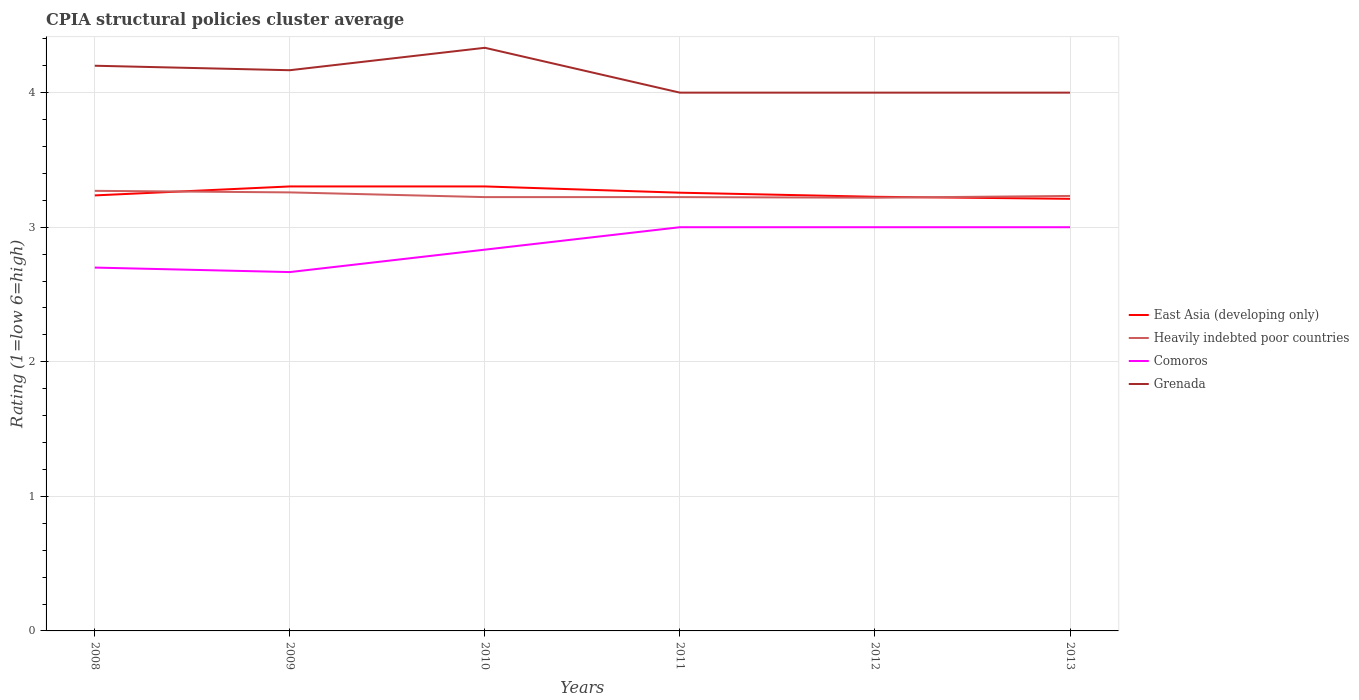How many different coloured lines are there?
Your response must be concise. 4. Is the number of lines equal to the number of legend labels?
Offer a terse response. Yes. Across all years, what is the maximum CPIA rating in East Asia (developing only)?
Offer a very short reply. 3.21. In which year was the CPIA rating in Grenada maximum?
Give a very brief answer. 2011. What is the total CPIA rating in Comoros in the graph?
Provide a succinct answer. 0.03. What is the difference between the highest and the second highest CPIA rating in Comoros?
Offer a very short reply. 0.33. How many lines are there?
Provide a succinct answer. 4. Does the graph contain any zero values?
Your answer should be compact. No. Where does the legend appear in the graph?
Provide a short and direct response. Center right. How many legend labels are there?
Offer a very short reply. 4. How are the legend labels stacked?
Make the answer very short. Vertical. What is the title of the graph?
Provide a succinct answer. CPIA structural policies cluster average. What is the Rating (1=low 6=high) in East Asia (developing only) in 2008?
Make the answer very short. 3.24. What is the Rating (1=low 6=high) of Heavily indebted poor countries in 2008?
Provide a succinct answer. 3.27. What is the Rating (1=low 6=high) of Comoros in 2008?
Your answer should be compact. 2.7. What is the Rating (1=low 6=high) of Grenada in 2008?
Make the answer very short. 4.2. What is the Rating (1=low 6=high) of East Asia (developing only) in 2009?
Provide a succinct answer. 3.3. What is the Rating (1=low 6=high) of Heavily indebted poor countries in 2009?
Your response must be concise. 3.26. What is the Rating (1=low 6=high) in Comoros in 2009?
Ensure brevity in your answer.  2.67. What is the Rating (1=low 6=high) in Grenada in 2009?
Keep it short and to the point. 4.17. What is the Rating (1=low 6=high) of East Asia (developing only) in 2010?
Your answer should be very brief. 3.3. What is the Rating (1=low 6=high) of Heavily indebted poor countries in 2010?
Your answer should be very brief. 3.22. What is the Rating (1=low 6=high) in Comoros in 2010?
Offer a very short reply. 2.83. What is the Rating (1=low 6=high) in Grenada in 2010?
Your answer should be very brief. 4.33. What is the Rating (1=low 6=high) of East Asia (developing only) in 2011?
Ensure brevity in your answer.  3.26. What is the Rating (1=low 6=high) in Heavily indebted poor countries in 2011?
Give a very brief answer. 3.22. What is the Rating (1=low 6=high) of Grenada in 2011?
Your answer should be very brief. 4. What is the Rating (1=low 6=high) of East Asia (developing only) in 2012?
Ensure brevity in your answer.  3.23. What is the Rating (1=low 6=high) in Heavily indebted poor countries in 2012?
Provide a succinct answer. 3.22. What is the Rating (1=low 6=high) of Comoros in 2012?
Your answer should be compact. 3. What is the Rating (1=low 6=high) in Grenada in 2012?
Provide a short and direct response. 4. What is the Rating (1=low 6=high) in East Asia (developing only) in 2013?
Ensure brevity in your answer.  3.21. What is the Rating (1=low 6=high) of Heavily indebted poor countries in 2013?
Provide a succinct answer. 3.23. What is the Rating (1=low 6=high) in Comoros in 2013?
Provide a short and direct response. 3. What is the Rating (1=low 6=high) of Grenada in 2013?
Ensure brevity in your answer.  4. Across all years, what is the maximum Rating (1=low 6=high) of East Asia (developing only)?
Your answer should be very brief. 3.3. Across all years, what is the maximum Rating (1=low 6=high) of Heavily indebted poor countries?
Provide a short and direct response. 3.27. Across all years, what is the maximum Rating (1=low 6=high) of Comoros?
Offer a terse response. 3. Across all years, what is the maximum Rating (1=low 6=high) of Grenada?
Keep it short and to the point. 4.33. Across all years, what is the minimum Rating (1=low 6=high) of East Asia (developing only)?
Provide a succinct answer. 3.21. Across all years, what is the minimum Rating (1=low 6=high) of Heavily indebted poor countries?
Provide a short and direct response. 3.22. Across all years, what is the minimum Rating (1=low 6=high) in Comoros?
Provide a short and direct response. 2.67. Across all years, what is the minimum Rating (1=low 6=high) in Grenada?
Your response must be concise. 4. What is the total Rating (1=low 6=high) of East Asia (developing only) in the graph?
Offer a terse response. 19.54. What is the total Rating (1=low 6=high) of Heavily indebted poor countries in the graph?
Provide a short and direct response. 19.43. What is the total Rating (1=low 6=high) of Grenada in the graph?
Make the answer very short. 24.7. What is the difference between the Rating (1=low 6=high) of East Asia (developing only) in 2008 and that in 2009?
Provide a succinct answer. -0.07. What is the difference between the Rating (1=low 6=high) of Heavily indebted poor countries in 2008 and that in 2009?
Ensure brevity in your answer.  0.01. What is the difference between the Rating (1=low 6=high) of East Asia (developing only) in 2008 and that in 2010?
Your answer should be very brief. -0.07. What is the difference between the Rating (1=low 6=high) in Heavily indebted poor countries in 2008 and that in 2010?
Provide a short and direct response. 0.05. What is the difference between the Rating (1=low 6=high) in Comoros in 2008 and that in 2010?
Make the answer very short. -0.13. What is the difference between the Rating (1=low 6=high) in Grenada in 2008 and that in 2010?
Make the answer very short. -0.13. What is the difference between the Rating (1=low 6=high) of East Asia (developing only) in 2008 and that in 2011?
Your response must be concise. -0.02. What is the difference between the Rating (1=low 6=high) in Heavily indebted poor countries in 2008 and that in 2011?
Make the answer very short. 0.05. What is the difference between the Rating (1=low 6=high) of Comoros in 2008 and that in 2011?
Give a very brief answer. -0.3. What is the difference between the Rating (1=low 6=high) of Grenada in 2008 and that in 2011?
Keep it short and to the point. 0.2. What is the difference between the Rating (1=low 6=high) of East Asia (developing only) in 2008 and that in 2012?
Keep it short and to the point. 0.01. What is the difference between the Rating (1=low 6=high) in Heavily indebted poor countries in 2008 and that in 2012?
Offer a terse response. 0.05. What is the difference between the Rating (1=low 6=high) in East Asia (developing only) in 2008 and that in 2013?
Keep it short and to the point. 0.03. What is the difference between the Rating (1=low 6=high) of Heavily indebted poor countries in 2008 and that in 2013?
Your answer should be very brief. 0.04. What is the difference between the Rating (1=low 6=high) of Heavily indebted poor countries in 2009 and that in 2010?
Give a very brief answer. 0.04. What is the difference between the Rating (1=low 6=high) in Comoros in 2009 and that in 2010?
Offer a very short reply. -0.17. What is the difference between the Rating (1=low 6=high) of East Asia (developing only) in 2009 and that in 2011?
Make the answer very short. 0.05. What is the difference between the Rating (1=low 6=high) in Heavily indebted poor countries in 2009 and that in 2011?
Your response must be concise. 0.04. What is the difference between the Rating (1=low 6=high) in Grenada in 2009 and that in 2011?
Your answer should be compact. 0.17. What is the difference between the Rating (1=low 6=high) of East Asia (developing only) in 2009 and that in 2012?
Make the answer very short. 0.08. What is the difference between the Rating (1=low 6=high) in Heavily indebted poor countries in 2009 and that in 2012?
Your response must be concise. 0.04. What is the difference between the Rating (1=low 6=high) in Comoros in 2009 and that in 2012?
Give a very brief answer. -0.33. What is the difference between the Rating (1=low 6=high) of East Asia (developing only) in 2009 and that in 2013?
Keep it short and to the point. 0.09. What is the difference between the Rating (1=low 6=high) in Heavily indebted poor countries in 2009 and that in 2013?
Provide a short and direct response. 0.03. What is the difference between the Rating (1=low 6=high) of East Asia (developing only) in 2010 and that in 2011?
Give a very brief answer. 0.05. What is the difference between the Rating (1=low 6=high) of Heavily indebted poor countries in 2010 and that in 2011?
Provide a short and direct response. 0. What is the difference between the Rating (1=low 6=high) of Grenada in 2010 and that in 2011?
Keep it short and to the point. 0.33. What is the difference between the Rating (1=low 6=high) in East Asia (developing only) in 2010 and that in 2012?
Offer a very short reply. 0.08. What is the difference between the Rating (1=low 6=high) of Heavily indebted poor countries in 2010 and that in 2012?
Your answer should be compact. 0. What is the difference between the Rating (1=low 6=high) in East Asia (developing only) in 2010 and that in 2013?
Provide a short and direct response. 0.09. What is the difference between the Rating (1=low 6=high) of Heavily indebted poor countries in 2010 and that in 2013?
Your answer should be very brief. -0.01. What is the difference between the Rating (1=low 6=high) of East Asia (developing only) in 2011 and that in 2012?
Offer a terse response. 0.03. What is the difference between the Rating (1=low 6=high) of Heavily indebted poor countries in 2011 and that in 2012?
Make the answer very short. 0. What is the difference between the Rating (1=low 6=high) in East Asia (developing only) in 2011 and that in 2013?
Make the answer very short. 0.05. What is the difference between the Rating (1=low 6=high) in Heavily indebted poor countries in 2011 and that in 2013?
Your answer should be compact. -0.01. What is the difference between the Rating (1=low 6=high) in East Asia (developing only) in 2012 and that in 2013?
Ensure brevity in your answer.  0.02. What is the difference between the Rating (1=low 6=high) in Heavily indebted poor countries in 2012 and that in 2013?
Make the answer very short. -0.01. What is the difference between the Rating (1=low 6=high) of East Asia (developing only) in 2008 and the Rating (1=low 6=high) of Heavily indebted poor countries in 2009?
Offer a very short reply. -0.02. What is the difference between the Rating (1=low 6=high) of East Asia (developing only) in 2008 and the Rating (1=low 6=high) of Comoros in 2009?
Make the answer very short. 0.57. What is the difference between the Rating (1=low 6=high) in East Asia (developing only) in 2008 and the Rating (1=low 6=high) in Grenada in 2009?
Keep it short and to the point. -0.93. What is the difference between the Rating (1=low 6=high) of Heavily indebted poor countries in 2008 and the Rating (1=low 6=high) of Comoros in 2009?
Offer a terse response. 0.6. What is the difference between the Rating (1=low 6=high) in Heavily indebted poor countries in 2008 and the Rating (1=low 6=high) in Grenada in 2009?
Offer a very short reply. -0.9. What is the difference between the Rating (1=low 6=high) in Comoros in 2008 and the Rating (1=low 6=high) in Grenada in 2009?
Your answer should be very brief. -1.47. What is the difference between the Rating (1=low 6=high) in East Asia (developing only) in 2008 and the Rating (1=low 6=high) in Heavily indebted poor countries in 2010?
Provide a short and direct response. 0.01. What is the difference between the Rating (1=low 6=high) of East Asia (developing only) in 2008 and the Rating (1=low 6=high) of Comoros in 2010?
Your response must be concise. 0.4. What is the difference between the Rating (1=low 6=high) of East Asia (developing only) in 2008 and the Rating (1=low 6=high) of Grenada in 2010?
Ensure brevity in your answer.  -1.1. What is the difference between the Rating (1=low 6=high) in Heavily indebted poor countries in 2008 and the Rating (1=low 6=high) in Comoros in 2010?
Offer a terse response. 0.44. What is the difference between the Rating (1=low 6=high) of Heavily indebted poor countries in 2008 and the Rating (1=low 6=high) of Grenada in 2010?
Your response must be concise. -1.06. What is the difference between the Rating (1=low 6=high) in Comoros in 2008 and the Rating (1=low 6=high) in Grenada in 2010?
Offer a terse response. -1.63. What is the difference between the Rating (1=low 6=high) in East Asia (developing only) in 2008 and the Rating (1=low 6=high) in Heavily indebted poor countries in 2011?
Your response must be concise. 0.01. What is the difference between the Rating (1=low 6=high) in East Asia (developing only) in 2008 and the Rating (1=low 6=high) in Comoros in 2011?
Offer a very short reply. 0.24. What is the difference between the Rating (1=low 6=high) in East Asia (developing only) in 2008 and the Rating (1=low 6=high) in Grenada in 2011?
Your answer should be compact. -0.76. What is the difference between the Rating (1=low 6=high) in Heavily indebted poor countries in 2008 and the Rating (1=low 6=high) in Comoros in 2011?
Provide a short and direct response. 0.27. What is the difference between the Rating (1=low 6=high) in Heavily indebted poor countries in 2008 and the Rating (1=low 6=high) in Grenada in 2011?
Provide a short and direct response. -0.73. What is the difference between the Rating (1=low 6=high) in Comoros in 2008 and the Rating (1=low 6=high) in Grenada in 2011?
Give a very brief answer. -1.3. What is the difference between the Rating (1=low 6=high) in East Asia (developing only) in 2008 and the Rating (1=low 6=high) in Heavily indebted poor countries in 2012?
Offer a terse response. 0.02. What is the difference between the Rating (1=low 6=high) of East Asia (developing only) in 2008 and the Rating (1=low 6=high) of Comoros in 2012?
Make the answer very short. 0.24. What is the difference between the Rating (1=low 6=high) of East Asia (developing only) in 2008 and the Rating (1=low 6=high) of Grenada in 2012?
Provide a short and direct response. -0.76. What is the difference between the Rating (1=low 6=high) in Heavily indebted poor countries in 2008 and the Rating (1=low 6=high) in Comoros in 2012?
Your answer should be very brief. 0.27. What is the difference between the Rating (1=low 6=high) of Heavily indebted poor countries in 2008 and the Rating (1=low 6=high) of Grenada in 2012?
Provide a short and direct response. -0.73. What is the difference between the Rating (1=low 6=high) in East Asia (developing only) in 2008 and the Rating (1=low 6=high) in Heavily indebted poor countries in 2013?
Offer a terse response. 0. What is the difference between the Rating (1=low 6=high) of East Asia (developing only) in 2008 and the Rating (1=low 6=high) of Comoros in 2013?
Your response must be concise. 0.24. What is the difference between the Rating (1=low 6=high) of East Asia (developing only) in 2008 and the Rating (1=low 6=high) of Grenada in 2013?
Your answer should be compact. -0.76. What is the difference between the Rating (1=low 6=high) of Heavily indebted poor countries in 2008 and the Rating (1=low 6=high) of Comoros in 2013?
Your response must be concise. 0.27. What is the difference between the Rating (1=low 6=high) in Heavily indebted poor countries in 2008 and the Rating (1=low 6=high) in Grenada in 2013?
Your answer should be very brief. -0.73. What is the difference between the Rating (1=low 6=high) in East Asia (developing only) in 2009 and the Rating (1=low 6=high) in Heavily indebted poor countries in 2010?
Make the answer very short. 0.08. What is the difference between the Rating (1=low 6=high) of East Asia (developing only) in 2009 and the Rating (1=low 6=high) of Comoros in 2010?
Make the answer very short. 0.47. What is the difference between the Rating (1=low 6=high) of East Asia (developing only) in 2009 and the Rating (1=low 6=high) of Grenada in 2010?
Offer a terse response. -1.03. What is the difference between the Rating (1=low 6=high) in Heavily indebted poor countries in 2009 and the Rating (1=low 6=high) in Comoros in 2010?
Your response must be concise. 0.43. What is the difference between the Rating (1=low 6=high) of Heavily indebted poor countries in 2009 and the Rating (1=low 6=high) of Grenada in 2010?
Offer a very short reply. -1.07. What is the difference between the Rating (1=low 6=high) in Comoros in 2009 and the Rating (1=low 6=high) in Grenada in 2010?
Your response must be concise. -1.67. What is the difference between the Rating (1=low 6=high) in East Asia (developing only) in 2009 and the Rating (1=low 6=high) in Heavily indebted poor countries in 2011?
Provide a succinct answer. 0.08. What is the difference between the Rating (1=low 6=high) in East Asia (developing only) in 2009 and the Rating (1=low 6=high) in Comoros in 2011?
Offer a terse response. 0.3. What is the difference between the Rating (1=low 6=high) in East Asia (developing only) in 2009 and the Rating (1=low 6=high) in Grenada in 2011?
Your answer should be very brief. -0.7. What is the difference between the Rating (1=low 6=high) in Heavily indebted poor countries in 2009 and the Rating (1=low 6=high) in Comoros in 2011?
Ensure brevity in your answer.  0.26. What is the difference between the Rating (1=low 6=high) in Heavily indebted poor countries in 2009 and the Rating (1=low 6=high) in Grenada in 2011?
Your response must be concise. -0.74. What is the difference between the Rating (1=low 6=high) in Comoros in 2009 and the Rating (1=low 6=high) in Grenada in 2011?
Your answer should be very brief. -1.33. What is the difference between the Rating (1=low 6=high) in East Asia (developing only) in 2009 and the Rating (1=low 6=high) in Heavily indebted poor countries in 2012?
Your answer should be very brief. 0.08. What is the difference between the Rating (1=low 6=high) of East Asia (developing only) in 2009 and the Rating (1=low 6=high) of Comoros in 2012?
Your answer should be compact. 0.3. What is the difference between the Rating (1=low 6=high) in East Asia (developing only) in 2009 and the Rating (1=low 6=high) in Grenada in 2012?
Offer a very short reply. -0.7. What is the difference between the Rating (1=low 6=high) of Heavily indebted poor countries in 2009 and the Rating (1=low 6=high) of Comoros in 2012?
Offer a very short reply. 0.26. What is the difference between the Rating (1=low 6=high) in Heavily indebted poor countries in 2009 and the Rating (1=low 6=high) in Grenada in 2012?
Provide a short and direct response. -0.74. What is the difference between the Rating (1=low 6=high) of Comoros in 2009 and the Rating (1=low 6=high) of Grenada in 2012?
Make the answer very short. -1.33. What is the difference between the Rating (1=low 6=high) in East Asia (developing only) in 2009 and the Rating (1=low 6=high) in Heavily indebted poor countries in 2013?
Provide a short and direct response. 0.07. What is the difference between the Rating (1=low 6=high) in East Asia (developing only) in 2009 and the Rating (1=low 6=high) in Comoros in 2013?
Ensure brevity in your answer.  0.3. What is the difference between the Rating (1=low 6=high) in East Asia (developing only) in 2009 and the Rating (1=low 6=high) in Grenada in 2013?
Offer a terse response. -0.7. What is the difference between the Rating (1=low 6=high) of Heavily indebted poor countries in 2009 and the Rating (1=low 6=high) of Comoros in 2013?
Offer a very short reply. 0.26. What is the difference between the Rating (1=low 6=high) in Heavily indebted poor countries in 2009 and the Rating (1=low 6=high) in Grenada in 2013?
Keep it short and to the point. -0.74. What is the difference between the Rating (1=low 6=high) in Comoros in 2009 and the Rating (1=low 6=high) in Grenada in 2013?
Your answer should be very brief. -1.33. What is the difference between the Rating (1=low 6=high) in East Asia (developing only) in 2010 and the Rating (1=low 6=high) in Heavily indebted poor countries in 2011?
Make the answer very short. 0.08. What is the difference between the Rating (1=low 6=high) of East Asia (developing only) in 2010 and the Rating (1=low 6=high) of Comoros in 2011?
Offer a very short reply. 0.3. What is the difference between the Rating (1=low 6=high) in East Asia (developing only) in 2010 and the Rating (1=low 6=high) in Grenada in 2011?
Your answer should be very brief. -0.7. What is the difference between the Rating (1=low 6=high) of Heavily indebted poor countries in 2010 and the Rating (1=low 6=high) of Comoros in 2011?
Keep it short and to the point. 0.22. What is the difference between the Rating (1=low 6=high) in Heavily indebted poor countries in 2010 and the Rating (1=low 6=high) in Grenada in 2011?
Your answer should be compact. -0.78. What is the difference between the Rating (1=low 6=high) in Comoros in 2010 and the Rating (1=low 6=high) in Grenada in 2011?
Ensure brevity in your answer.  -1.17. What is the difference between the Rating (1=low 6=high) in East Asia (developing only) in 2010 and the Rating (1=low 6=high) in Heavily indebted poor countries in 2012?
Offer a very short reply. 0.08. What is the difference between the Rating (1=low 6=high) in East Asia (developing only) in 2010 and the Rating (1=low 6=high) in Comoros in 2012?
Your answer should be compact. 0.3. What is the difference between the Rating (1=low 6=high) in East Asia (developing only) in 2010 and the Rating (1=low 6=high) in Grenada in 2012?
Offer a very short reply. -0.7. What is the difference between the Rating (1=low 6=high) in Heavily indebted poor countries in 2010 and the Rating (1=low 6=high) in Comoros in 2012?
Your answer should be very brief. 0.22. What is the difference between the Rating (1=low 6=high) of Heavily indebted poor countries in 2010 and the Rating (1=low 6=high) of Grenada in 2012?
Offer a very short reply. -0.78. What is the difference between the Rating (1=low 6=high) in Comoros in 2010 and the Rating (1=low 6=high) in Grenada in 2012?
Offer a terse response. -1.17. What is the difference between the Rating (1=low 6=high) in East Asia (developing only) in 2010 and the Rating (1=low 6=high) in Heavily indebted poor countries in 2013?
Keep it short and to the point. 0.07. What is the difference between the Rating (1=low 6=high) of East Asia (developing only) in 2010 and the Rating (1=low 6=high) of Comoros in 2013?
Provide a short and direct response. 0.3. What is the difference between the Rating (1=low 6=high) in East Asia (developing only) in 2010 and the Rating (1=low 6=high) in Grenada in 2013?
Your answer should be compact. -0.7. What is the difference between the Rating (1=low 6=high) of Heavily indebted poor countries in 2010 and the Rating (1=low 6=high) of Comoros in 2013?
Provide a short and direct response. 0.22. What is the difference between the Rating (1=low 6=high) of Heavily indebted poor countries in 2010 and the Rating (1=low 6=high) of Grenada in 2013?
Provide a short and direct response. -0.78. What is the difference between the Rating (1=low 6=high) of Comoros in 2010 and the Rating (1=low 6=high) of Grenada in 2013?
Provide a succinct answer. -1.17. What is the difference between the Rating (1=low 6=high) of East Asia (developing only) in 2011 and the Rating (1=low 6=high) of Heavily indebted poor countries in 2012?
Ensure brevity in your answer.  0.04. What is the difference between the Rating (1=low 6=high) of East Asia (developing only) in 2011 and the Rating (1=low 6=high) of Comoros in 2012?
Keep it short and to the point. 0.26. What is the difference between the Rating (1=low 6=high) in East Asia (developing only) in 2011 and the Rating (1=low 6=high) in Grenada in 2012?
Ensure brevity in your answer.  -0.74. What is the difference between the Rating (1=low 6=high) in Heavily indebted poor countries in 2011 and the Rating (1=low 6=high) in Comoros in 2012?
Ensure brevity in your answer.  0.22. What is the difference between the Rating (1=low 6=high) in Heavily indebted poor countries in 2011 and the Rating (1=low 6=high) in Grenada in 2012?
Provide a succinct answer. -0.78. What is the difference between the Rating (1=low 6=high) of Comoros in 2011 and the Rating (1=low 6=high) of Grenada in 2012?
Offer a very short reply. -1. What is the difference between the Rating (1=low 6=high) of East Asia (developing only) in 2011 and the Rating (1=low 6=high) of Heavily indebted poor countries in 2013?
Make the answer very short. 0.02. What is the difference between the Rating (1=low 6=high) in East Asia (developing only) in 2011 and the Rating (1=low 6=high) in Comoros in 2013?
Offer a terse response. 0.26. What is the difference between the Rating (1=low 6=high) in East Asia (developing only) in 2011 and the Rating (1=low 6=high) in Grenada in 2013?
Offer a very short reply. -0.74. What is the difference between the Rating (1=low 6=high) in Heavily indebted poor countries in 2011 and the Rating (1=low 6=high) in Comoros in 2013?
Your response must be concise. 0.22. What is the difference between the Rating (1=low 6=high) of Heavily indebted poor countries in 2011 and the Rating (1=low 6=high) of Grenada in 2013?
Your answer should be very brief. -0.78. What is the difference between the Rating (1=low 6=high) in Comoros in 2011 and the Rating (1=low 6=high) in Grenada in 2013?
Provide a succinct answer. -1. What is the difference between the Rating (1=low 6=high) of East Asia (developing only) in 2012 and the Rating (1=low 6=high) of Heavily indebted poor countries in 2013?
Make the answer very short. -0.01. What is the difference between the Rating (1=low 6=high) in East Asia (developing only) in 2012 and the Rating (1=low 6=high) in Comoros in 2013?
Keep it short and to the point. 0.23. What is the difference between the Rating (1=low 6=high) of East Asia (developing only) in 2012 and the Rating (1=low 6=high) of Grenada in 2013?
Provide a succinct answer. -0.77. What is the difference between the Rating (1=low 6=high) of Heavily indebted poor countries in 2012 and the Rating (1=low 6=high) of Comoros in 2013?
Provide a short and direct response. 0.22. What is the difference between the Rating (1=low 6=high) in Heavily indebted poor countries in 2012 and the Rating (1=low 6=high) in Grenada in 2013?
Your answer should be compact. -0.78. What is the difference between the Rating (1=low 6=high) of Comoros in 2012 and the Rating (1=low 6=high) of Grenada in 2013?
Give a very brief answer. -1. What is the average Rating (1=low 6=high) in East Asia (developing only) per year?
Provide a succinct answer. 3.26. What is the average Rating (1=low 6=high) in Heavily indebted poor countries per year?
Make the answer very short. 3.24. What is the average Rating (1=low 6=high) in Comoros per year?
Ensure brevity in your answer.  2.87. What is the average Rating (1=low 6=high) in Grenada per year?
Provide a short and direct response. 4.12. In the year 2008, what is the difference between the Rating (1=low 6=high) of East Asia (developing only) and Rating (1=low 6=high) of Heavily indebted poor countries?
Ensure brevity in your answer.  -0.03. In the year 2008, what is the difference between the Rating (1=low 6=high) of East Asia (developing only) and Rating (1=low 6=high) of Comoros?
Provide a short and direct response. 0.54. In the year 2008, what is the difference between the Rating (1=low 6=high) of East Asia (developing only) and Rating (1=low 6=high) of Grenada?
Provide a succinct answer. -0.96. In the year 2008, what is the difference between the Rating (1=low 6=high) of Heavily indebted poor countries and Rating (1=low 6=high) of Comoros?
Make the answer very short. 0.57. In the year 2008, what is the difference between the Rating (1=low 6=high) in Heavily indebted poor countries and Rating (1=low 6=high) in Grenada?
Provide a short and direct response. -0.93. In the year 2009, what is the difference between the Rating (1=low 6=high) in East Asia (developing only) and Rating (1=low 6=high) in Heavily indebted poor countries?
Offer a very short reply. 0.04. In the year 2009, what is the difference between the Rating (1=low 6=high) of East Asia (developing only) and Rating (1=low 6=high) of Comoros?
Your answer should be compact. 0.64. In the year 2009, what is the difference between the Rating (1=low 6=high) of East Asia (developing only) and Rating (1=low 6=high) of Grenada?
Provide a succinct answer. -0.86. In the year 2009, what is the difference between the Rating (1=low 6=high) in Heavily indebted poor countries and Rating (1=low 6=high) in Comoros?
Your response must be concise. 0.59. In the year 2009, what is the difference between the Rating (1=low 6=high) in Heavily indebted poor countries and Rating (1=low 6=high) in Grenada?
Make the answer very short. -0.91. In the year 2010, what is the difference between the Rating (1=low 6=high) of East Asia (developing only) and Rating (1=low 6=high) of Heavily indebted poor countries?
Make the answer very short. 0.08. In the year 2010, what is the difference between the Rating (1=low 6=high) in East Asia (developing only) and Rating (1=low 6=high) in Comoros?
Provide a succinct answer. 0.47. In the year 2010, what is the difference between the Rating (1=low 6=high) of East Asia (developing only) and Rating (1=low 6=high) of Grenada?
Give a very brief answer. -1.03. In the year 2010, what is the difference between the Rating (1=low 6=high) in Heavily indebted poor countries and Rating (1=low 6=high) in Comoros?
Make the answer very short. 0.39. In the year 2010, what is the difference between the Rating (1=low 6=high) in Heavily indebted poor countries and Rating (1=low 6=high) in Grenada?
Ensure brevity in your answer.  -1.11. In the year 2011, what is the difference between the Rating (1=low 6=high) in East Asia (developing only) and Rating (1=low 6=high) in Heavily indebted poor countries?
Your answer should be compact. 0.03. In the year 2011, what is the difference between the Rating (1=low 6=high) in East Asia (developing only) and Rating (1=low 6=high) in Comoros?
Your answer should be compact. 0.26. In the year 2011, what is the difference between the Rating (1=low 6=high) of East Asia (developing only) and Rating (1=low 6=high) of Grenada?
Provide a short and direct response. -0.74. In the year 2011, what is the difference between the Rating (1=low 6=high) in Heavily indebted poor countries and Rating (1=low 6=high) in Comoros?
Your response must be concise. 0.22. In the year 2011, what is the difference between the Rating (1=low 6=high) of Heavily indebted poor countries and Rating (1=low 6=high) of Grenada?
Offer a very short reply. -0.78. In the year 2012, what is the difference between the Rating (1=low 6=high) of East Asia (developing only) and Rating (1=low 6=high) of Heavily indebted poor countries?
Keep it short and to the point. 0.01. In the year 2012, what is the difference between the Rating (1=low 6=high) of East Asia (developing only) and Rating (1=low 6=high) of Comoros?
Provide a succinct answer. 0.23. In the year 2012, what is the difference between the Rating (1=low 6=high) of East Asia (developing only) and Rating (1=low 6=high) of Grenada?
Keep it short and to the point. -0.77. In the year 2012, what is the difference between the Rating (1=low 6=high) of Heavily indebted poor countries and Rating (1=low 6=high) of Comoros?
Offer a very short reply. 0.22. In the year 2012, what is the difference between the Rating (1=low 6=high) in Heavily indebted poor countries and Rating (1=low 6=high) in Grenada?
Your answer should be very brief. -0.78. In the year 2012, what is the difference between the Rating (1=low 6=high) in Comoros and Rating (1=low 6=high) in Grenada?
Your answer should be very brief. -1. In the year 2013, what is the difference between the Rating (1=low 6=high) of East Asia (developing only) and Rating (1=low 6=high) of Heavily indebted poor countries?
Offer a terse response. -0.02. In the year 2013, what is the difference between the Rating (1=low 6=high) in East Asia (developing only) and Rating (1=low 6=high) in Comoros?
Provide a succinct answer. 0.21. In the year 2013, what is the difference between the Rating (1=low 6=high) in East Asia (developing only) and Rating (1=low 6=high) in Grenada?
Your response must be concise. -0.79. In the year 2013, what is the difference between the Rating (1=low 6=high) of Heavily indebted poor countries and Rating (1=low 6=high) of Comoros?
Ensure brevity in your answer.  0.23. In the year 2013, what is the difference between the Rating (1=low 6=high) in Heavily indebted poor countries and Rating (1=low 6=high) in Grenada?
Your response must be concise. -0.77. What is the ratio of the Rating (1=low 6=high) of East Asia (developing only) in 2008 to that in 2009?
Your response must be concise. 0.98. What is the ratio of the Rating (1=low 6=high) in Heavily indebted poor countries in 2008 to that in 2009?
Give a very brief answer. 1. What is the ratio of the Rating (1=low 6=high) of Comoros in 2008 to that in 2009?
Provide a succinct answer. 1.01. What is the ratio of the Rating (1=low 6=high) in East Asia (developing only) in 2008 to that in 2010?
Keep it short and to the point. 0.98. What is the ratio of the Rating (1=low 6=high) in Heavily indebted poor countries in 2008 to that in 2010?
Your answer should be very brief. 1.01. What is the ratio of the Rating (1=low 6=high) in Comoros in 2008 to that in 2010?
Make the answer very short. 0.95. What is the ratio of the Rating (1=low 6=high) of Grenada in 2008 to that in 2010?
Make the answer very short. 0.97. What is the ratio of the Rating (1=low 6=high) in Heavily indebted poor countries in 2008 to that in 2011?
Provide a short and direct response. 1.01. What is the ratio of the Rating (1=low 6=high) of East Asia (developing only) in 2008 to that in 2012?
Keep it short and to the point. 1. What is the ratio of the Rating (1=low 6=high) in Heavily indebted poor countries in 2008 to that in 2012?
Your answer should be very brief. 1.02. What is the ratio of the Rating (1=low 6=high) of East Asia (developing only) in 2008 to that in 2013?
Give a very brief answer. 1.01. What is the ratio of the Rating (1=low 6=high) in Heavily indebted poor countries in 2008 to that in 2013?
Provide a short and direct response. 1.01. What is the ratio of the Rating (1=low 6=high) in Grenada in 2008 to that in 2013?
Offer a very short reply. 1.05. What is the ratio of the Rating (1=low 6=high) in Heavily indebted poor countries in 2009 to that in 2010?
Offer a very short reply. 1.01. What is the ratio of the Rating (1=low 6=high) in Grenada in 2009 to that in 2010?
Provide a short and direct response. 0.96. What is the ratio of the Rating (1=low 6=high) of East Asia (developing only) in 2009 to that in 2011?
Provide a short and direct response. 1.01. What is the ratio of the Rating (1=low 6=high) of Heavily indebted poor countries in 2009 to that in 2011?
Offer a terse response. 1.01. What is the ratio of the Rating (1=low 6=high) in Grenada in 2009 to that in 2011?
Keep it short and to the point. 1.04. What is the ratio of the Rating (1=low 6=high) in East Asia (developing only) in 2009 to that in 2012?
Your response must be concise. 1.02. What is the ratio of the Rating (1=low 6=high) of Heavily indebted poor countries in 2009 to that in 2012?
Ensure brevity in your answer.  1.01. What is the ratio of the Rating (1=low 6=high) in Grenada in 2009 to that in 2012?
Provide a short and direct response. 1.04. What is the ratio of the Rating (1=low 6=high) in East Asia (developing only) in 2009 to that in 2013?
Offer a very short reply. 1.03. What is the ratio of the Rating (1=low 6=high) in Heavily indebted poor countries in 2009 to that in 2013?
Your answer should be very brief. 1.01. What is the ratio of the Rating (1=low 6=high) in Grenada in 2009 to that in 2013?
Offer a very short reply. 1.04. What is the ratio of the Rating (1=low 6=high) in East Asia (developing only) in 2010 to that in 2011?
Offer a terse response. 1.01. What is the ratio of the Rating (1=low 6=high) in Heavily indebted poor countries in 2010 to that in 2011?
Provide a succinct answer. 1. What is the ratio of the Rating (1=low 6=high) of East Asia (developing only) in 2010 to that in 2012?
Keep it short and to the point. 1.02. What is the ratio of the Rating (1=low 6=high) of Comoros in 2010 to that in 2012?
Ensure brevity in your answer.  0.94. What is the ratio of the Rating (1=low 6=high) in East Asia (developing only) in 2010 to that in 2013?
Offer a very short reply. 1.03. What is the ratio of the Rating (1=low 6=high) in Grenada in 2010 to that in 2013?
Your answer should be compact. 1.08. What is the ratio of the Rating (1=low 6=high) of East Asia (developing only) in 2011 to that in 2012?
Make the answer very short. 1.01. What is the ratio of the Rating (1=low 6=high) of Comoros in 2011 to that in 2012?
Your answer should be compact. 1. What is the ratio of the Rating (1=low 6=high) of East Asia (developing only) in 2011 to that in 2013?
Provide a succinct answer. 1.01. What is the ratio of the Rating (1=low 6=high) of Comoros in 2011 to that in 2013?
Keep it short and to the point. 1. What is the ratio of the Rating (1=low 6=high) of East Asia (developing only) in 2012 to that in 2013?
Your answer should be compact. 1. What is the ratio of the Rating (1=low 6=high) in Comoros in 2012 to that in 2013?
Give a very brief answer. 1. What is the difference between the highest and the second highest Rating (1=low 6=high) in Heavily indebted poor countries?
Offer a terse response. 0.01. What is the difference between the highest and the second highest Rating (1=low 6=high) of Comoros?
Offer a very short reply. 0. What is the difference between the highest and the second highest Rating (1=low 6=high) in Grenada?
Ensure brevity in your answer.  0.13. What is the difference between the highest and the lowest Rating (1=low 6=high) in East Asia (developing only)?
Provide a succinct answer. 0.09. What is the difference between the highest and the lowest Rating (1=low 6=high) in Heavily indebted poor countries?
Offer a very short reply. 0.05. 